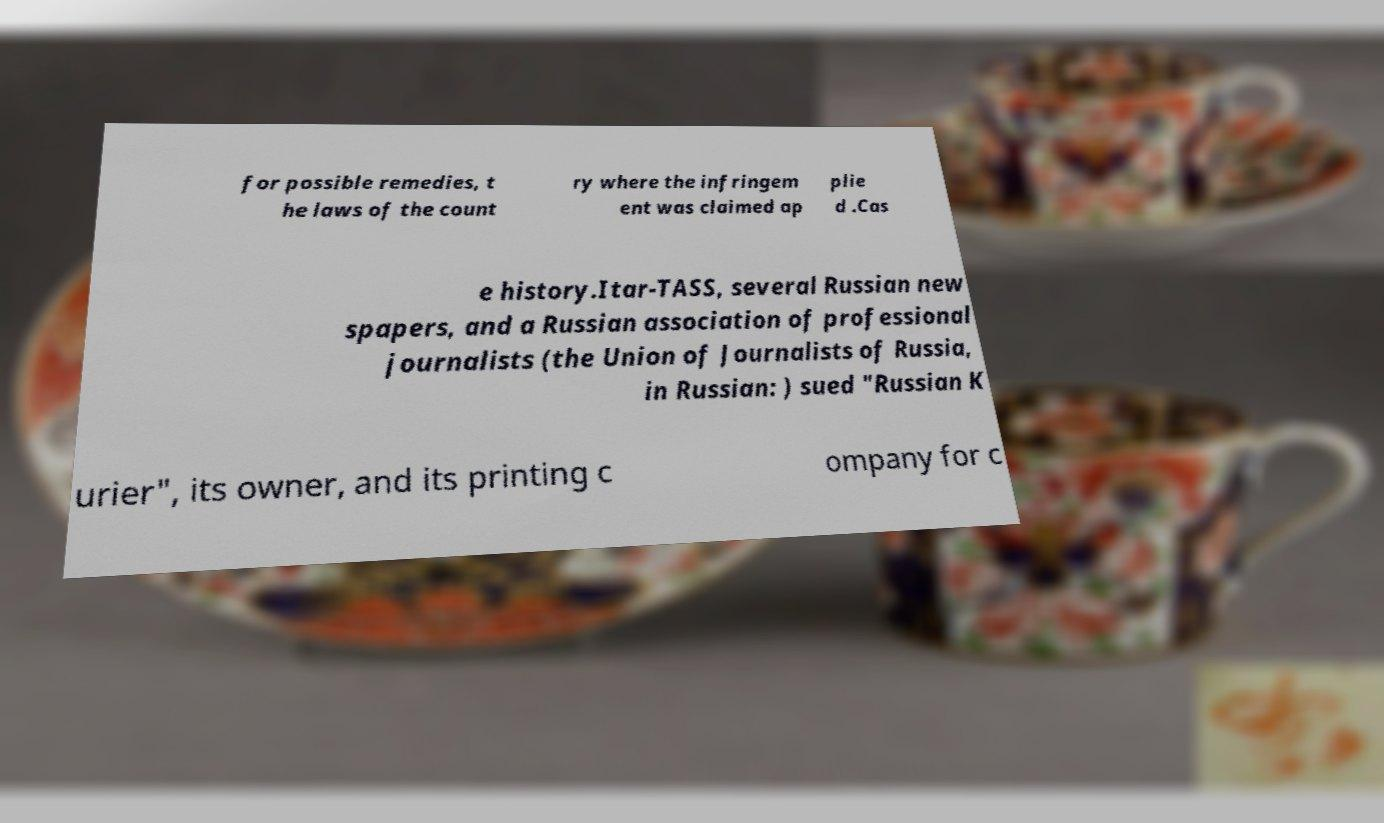Please read and relay the text visible in this image. What does it say? for possible remedies, t he laws of the count ry where the infringem ent was claimed ap plie d .Cas e history.Itar-TASS, several Russian new spapers, and a Russian association of professional journalists (the Union of Journalists of Russia, in Russian: ) sued "Russian K urier", its owner, and its printing c ompany for c 